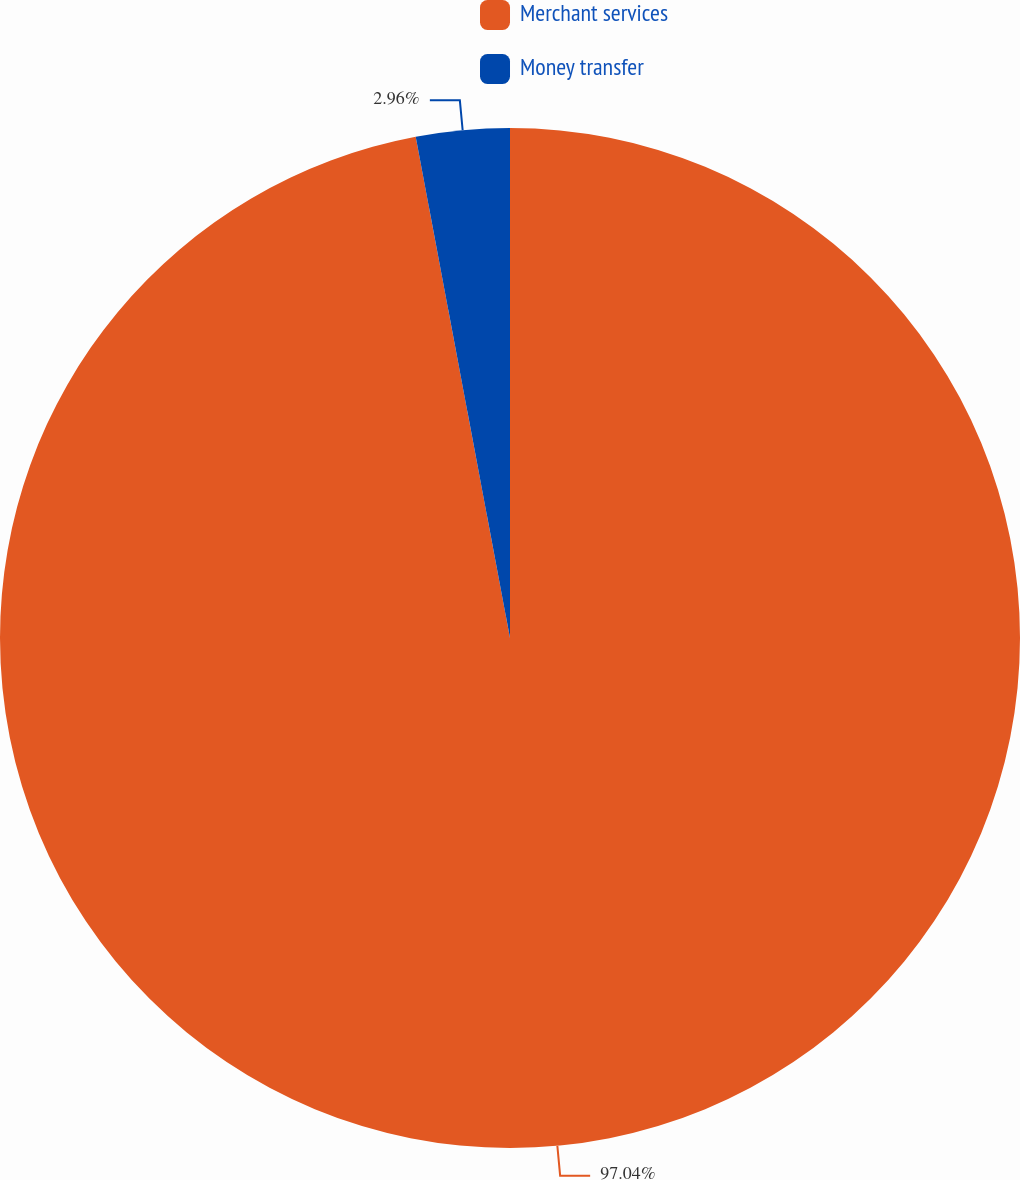Convert chart to OTSL. <chart><loc_0><loc_0><loc_500><loc_500><pie_chart><fcel>Merchant services<fcel>Money transfer<nl><fcel>97.04%<fcel>2.96%<nl></chart> 